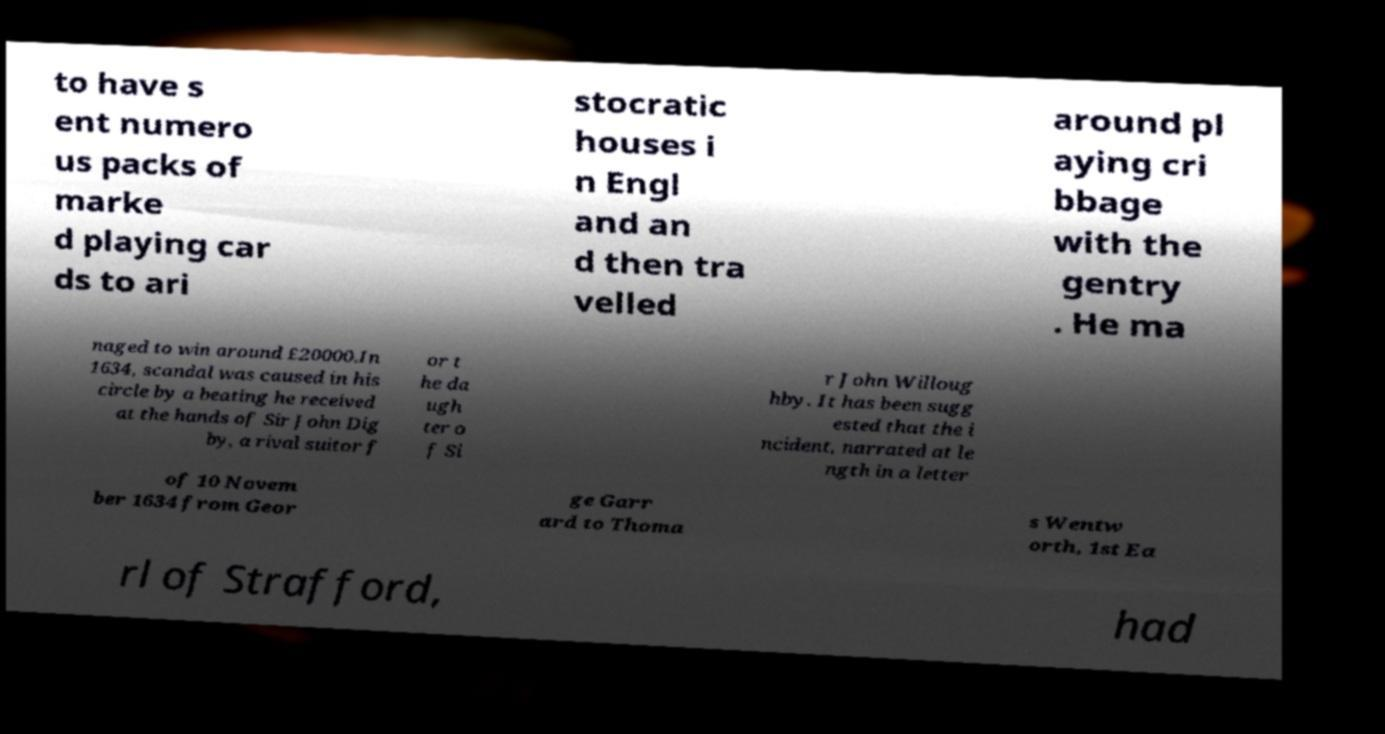Could you assist in decoding the text presented in this image and type it out clearly? to have s ent numero us packs of marke d playing car ds to ari stocratic houses i n Engl and an d then tra velled around pl aying cri bbage with the gentry . He ma naged to win around £20000.In 1634, scandal was caused in his circle by a beating he received at the hands of Sir John Dig by, a rival suitor f or t he da ugh ter o f Si r John Willoug hby. It has been sugg ested that the i ncident, narrated at le ngth in a letter of 10 Novem ber 1634 from Geor ge Garr ard to Thoma s Wentw orth, 1st Ea rl of Strafford, had 